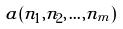Convert formula to latex. <formula><loc_0><loc_0><loc_500><loc_500>a ( n _ { 1 } , n _ { 2 } , \dots , n _ { m } )</formula> 